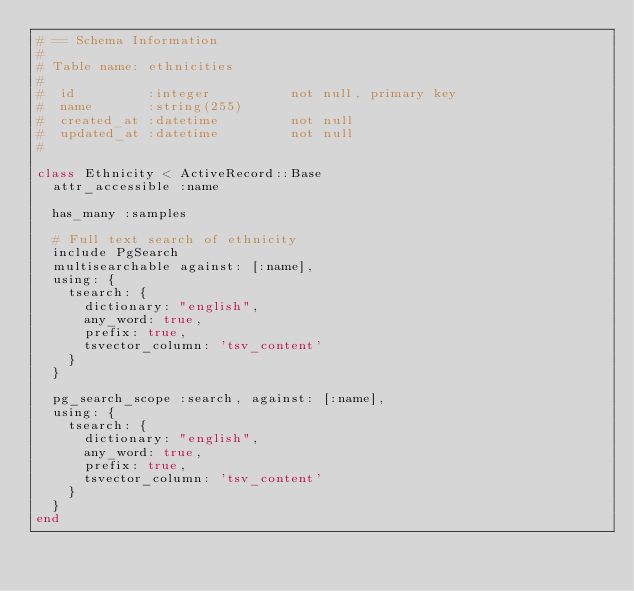Convert code to text. <code><loc_0><loc_0><loc_500><loc_500><_Ruby_># == Schema Information
#
# Table name: ethnicities
#
#  id         :integer          not null, primary key
#  name       :string(255)
#  created_at :datetime         not null
#  updated_at :datetime         not null
#

class Ethnicity < ActiveRecord::Base
  attr_accessible :name

  has_many :samples

  # Full text search of ethnicity
  include PgSearch
  multisearchable against: [:name],
  using: {
    tsearch: {
      dictionary: "english",
      any_word: true,
      prefix: true,
      tsvector_column: 'tsv_content'
    }
  }

  pg_search_scope :search, against: [:name],
  using: {
    tsearch: {
      dictionary: "english",
      any_word: true,
      prefix: true,
      tsvector_column: 'tsv_content'
    }
  }
end
</code> 